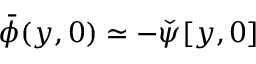<formula> <loc_0><loc_0><loc_500><loc_500>\bar { \phi } ( y , 0 ) \simeq - { \check { \psi } } [ y , 0 ]</formula> 